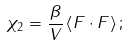Convert formula to latex. <formula><loc_0><loc_0><loc_500><loc_500>\chi _ { 2 } = \frac { \beta } { V } \left \langle F \cdot F \right \rangle ;</formula> 